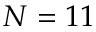<formula> <loc_0><loc_0><loc_500><loc_500>N = 1 1</formula> 